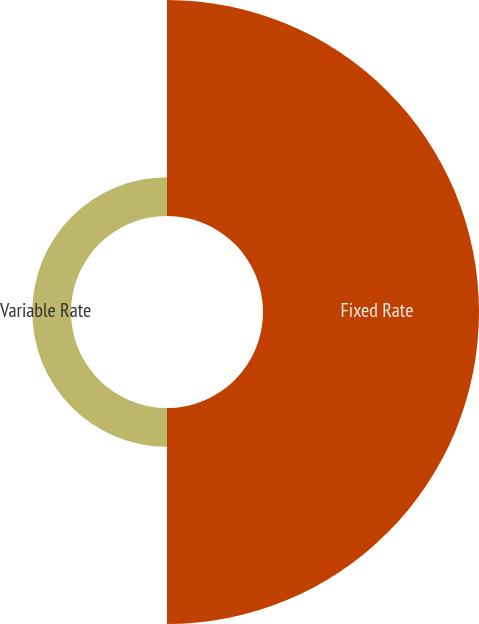<chart> <loc_0><loc_0><loc_500><loc_500><pie_chart><fcel>Fixed Rate<fcel>Variable Rate<nl><fcel>84.8%<fcel>15.2%<nl></chart> 